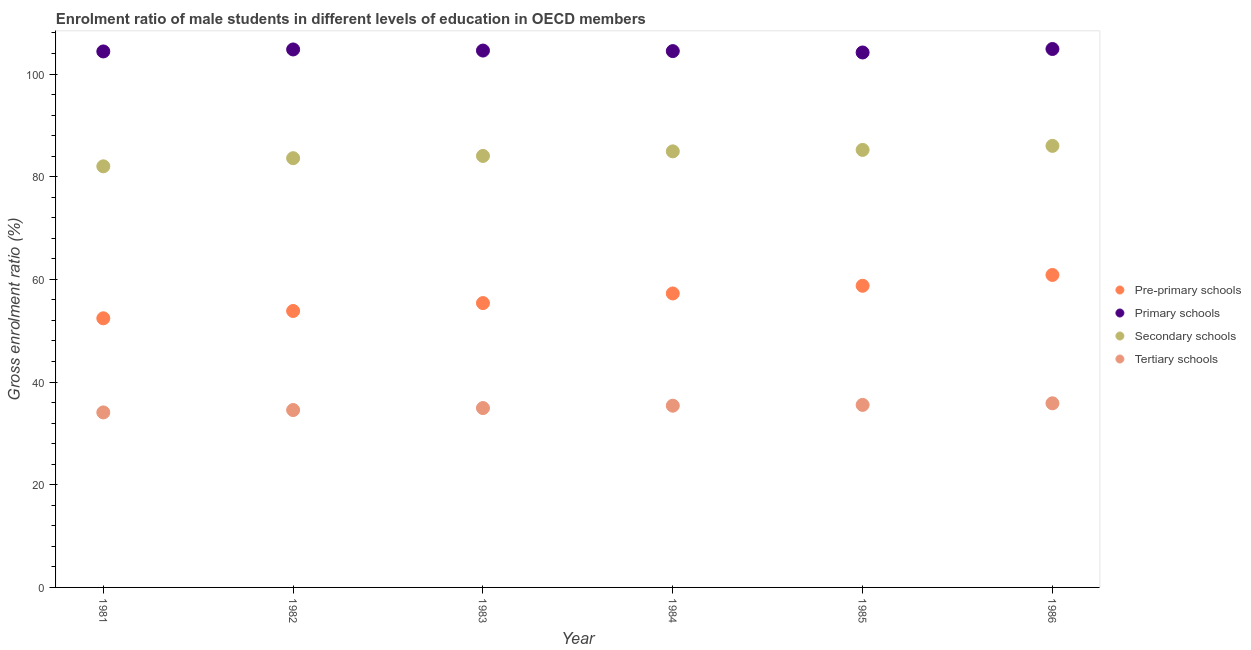How many different coloured dotlines are there?
Give a very brief answer. 4. What is the gross enrolment ratio(female) in primary schools in 1986?
Give a very brief answer. 104.87. Across all years, what is the maximum gross enrolment ratio(female) in primary schools?
Keep it short and to the point. 104.87. Across all years, what is the minimum gross enrolment ratio(female) in pre-primary schools?
Give a very brief answer. 52.42. What is the total gross enrolment ratio(female) in primary schools in the graph?
Give a very brief answer. 627.28. What is the difference between the gross enrolment ratio(female) in secondary schools in 1982 and that in 1986?
Provide a succinct answer. -2.4. What is the difference between the gross enrolment ratio(female) in pre-primary schools in 1985 and the gross enrolment ratio(female) in secondary schools in 1981?
Offer a very short reply. -23.27. What is the average gross enrolment ratio(female) in secondary schools per year?
Keep it short and to the point. 84.3. In the year 1981, what is the difference between the gross enrolment ratio(female) in primary schools and gross enrolment ratio(female) in tertiary schools?
Offer a very short reply. 70.31. What is the ratio of the gross enrolment ratio(female) in pre-primary schools in 1981 to that in 1983?
Provide a succinct answer. 0.95. Is the difference between the gross enrolment ratio(female) in pre-primary schools in 1982 and 1985 greater than the difference between the gross enrolment ratio(female) in primary schools in 1982 and 1985?
Offer a terse response. No. What is the difference between the highest and the second highest gross enrolment ratio(female) in primary schools?
Ensure brevity in your answer.  0.09. What is the difference between the highest and the lowest gross enrolment ratio(female) in secondary schools?
Your answer should be compact. 3.98. How many years are there in the graph?
Your answer should be compact. 6. Are the values on the major ticks of Y-axis written in scientific E-notation?
Your response must be concise. No. Where does the legend appear in the graph?
Your answer should be compact. Center right. How are the legend labels stacked?
Give a very brief answer. Vertical. What is the title of the graph?
Your answer should be compact. Enrolment ratio of male students in different levels of education in OECD members. What is the label or title of the Y-axis?
Offer a very short reply. Gross enrolment ratio (%). What is the Gross enrolment ratio (%) in Pre-primary schools in 1981?
Ensure brevity in your answer.  52.42. What is the Gross enrolment ratio (%) of Primary schools in 1981?
Ensure brevity in your answer.  104.4. What is the Gross enrolment ratio (%) in Secondary schools in 1981?
Keep it short and to the point. 82.02. What is the Gross enrolment ratio (%) in Tertiary schools in 1981?
Provide a succinct answer. 34.09. What is the Gross enrolment ratio (%) in Pre-primary schools in 1982?
Make the answer very short. 53.84. What is the Gross enrolment ratio (%) of Primary schools in 1982?
Provide a succinct answer. 104.78. What is the Gross enrolment ratio (%) of Secondary schools in 1982?
Your answer should be compact. 83.6. What is the Gross enrolment ratio (%) of Tertiary schools in 1982?
Make the answer very short. 34.55. What is the Gross enrolment ratio (%) in Pre-primary schools in 1983?
Offer a terse response. 55.38. What is the Gross enrolment ratio (%) in Primary schools in 1983?
Make the answer very short. 104.57. What is the Gross enrolment ratio (%) of Secondary schools in 1983?
Make the answer very short. 84.05. What is the Gross enrolment ratio (%) of Tertiary schools in 1983?
Make the answer very short. 34.94. What is the Gross enrolment ratio (%) in Pre-primary schools in 1984?
Your response must be concise. 57.26. What is the Gross enrolment ratio (%) of Primary schools in 1984?
Provide a short and direct response. 104.46. What is the Gross enrolment ratio (%) in Secondary schools in 1984?
Provide a succinct answer. 84.93. What is the Gross enrolment ratio (%) in Tertiary schools in 1984?
Offer a terse response. 35.4. What is the Gross enrolment ratio (%) of Pre-primary schools in 1985?
Your answer should be very brief. 58.76. What is the Gross enrolment ratio (%) of Primary schools in 1985?
Keep it short and to the point. 104.19. What is the Gross enrolment ratio (%) of Secondary schools in 1985?
Offer a very short reply. 85.22. What is the Gross enrolment ratio (%) of Tertiary schools in 1985?
Offer a very short reply. 35.55. What is the Gross enrolment ratio (%) of Pre-primary schools in 1986?
Keep it short and to the point. 60.86. What is the Gross enrolment ratio (%) in Primary schools in 1986?
Provide a short and direct response. 104.87. What is the Gross enrolment ratio (%) of Secondary schools in 1986?
Keep it short and to the point. 86. What is the Gross enrolment ratio (%) of Tertiary schools in 1986?
Keep it short and to the point. 35.86. Across all years, what is the maximum Gross enrolment ratio (%) in Pre-primary schools?
Provide a short and direct response. 60.86. Across all years, what is the maximum Gross enrolment ratio (%) in Primary schools?
Ensure brevity in your answer.  104.87. Across all years, what is the maximum Gross enrolment ratio (%) in Secondary schools?
Ensure brevity in your answer.  86. Across all years, what is the maximum Gross enrolment ratio (%) of Tertiary schools?
Keep it short and to the point. 35.86. Across all years, what is the minimum Gross enrolment ratio (%) of Pre-primary schools?
Your answer should be very brief. 52.42. Across all years, what is the minimum Gross enrolment ratio (%) in Primary schools?
Your response must be concise. 104.19. Across all years, what is the minimum Gross enrolment ratio (%) in Secondary schools?
Your answer should be very brief. 82.02. Across all years, what is the minimum Gross enrolment ratio (%) of Tertiary schools?
Make the answer very short. 34.09. What is the total Gross enrolment ratio (%) of Pre-primary schools in the graph?
Your answer should be compact. 338.52. What is the total Gross enrolment ratio (%) in Primary schools in the graph?
Give a very brief answer. 627.28. What is the total Gross enrolment ratio (%) of Secondary schools in the graph?
Your answer should be very brief. 505.83. What is the total Gross enrolment ratio (%) in Tertiary schools in the graph?
Your answer should be very brief. 210.39. What is the difference between the Gross enrolment ratio (%) in Pre-primary schools in 1981 and that in 1982?
Your response must be concise. -1.42. What is the difference between the Gross enrolment ratio (%) of Primary schools in 1981 and that in 1982?
Offer a terse response. -0.39. What is the difference between the Gross enrolment ratio (%) of Secondary schools in 1981 and that in 1982?
Your answer should be compact. -1.58. What is the difference between the Gross enrolment ratio (%) of Tertiary schools in 1981 and that in 1982?
Your answer should be compact. -0.46. What is the difference between the Gross enrolment ratio (%) in Pre-primary schools in 1981 and that in 1983?
Provide a short and direct response. -2.96. What is the difference between the Gross enrolment ratio (%) of Primary schools in 1981 and that in 1983?
Offer a very short reply. -0.17. What is the difference between the Gross enrolment ratio (%) in Secondary schools in 1981 and that in 1983?
Keep it short and to the point. -2.02. What is the difference between the Gross enrolment ratio (%) in Tertiary schools in 1981 and that in 1983?
Keep it short and to the point. -0.85. What is the difference between the Gross enrolment ratio (%) in Pre-primary schools in 1981 and that in 1984?
Offer a terse response. -4.84. What is the difference between the Gross enrolment ratio (%) in Primary schools in 1981 and that in 1984?
Offer a terse response. -0.07. What is the difference between the Gross enrolment ratio (%) in Secondary schools in 1981 and that in 1984?
Ensure brevity in your answer.  -2.91. What is the difference between the Gross enrolment ratio (%) in Tertiary schools in 1981 and that in 1984?
Your response must be concise. -1.31. What is the difference between the Gross enrolment ratio (%) in Pre-primary schools in 1981 and that in 1985?
Offer a terse response. -6.34. What is the difference between the Gross enrolment ratio (%) of Primary schools in 1981 and that in 1985?
Offer a very short reply. 0.2. What is the difference between the Gross enrolment ratio (%) of Secondary schools in 1981 and that in 1985?
Offer a terse response. -3.2. What is the difference between the Gross enrolment ratio (%) of Tertiary schools in 1981 and that in 1985?
Your response must be concise. -1.46. What is the difference between the Gross enrolment ratio (%) of Pre-primary schools in 1981 and that in 1986?
Provide a short and direct response. -8.44. What is the difference between the Gross enrolment ratio (%) of Primary schools in 1981 and that in 1986?
Keep it short and to the point. -0.48. What is the difference between the Gross enrolment ratio (%) of Secondary schools in 1981 and that in 1986?
Offer a terse response. -3.98. What is the difference between the Gross enrolment ratio (%) of Tertiary schools in 1981 and that in 1986?
Offer a very short reply. -1.78. What is the difference between the Gross enrolment ratio (%) of Pre-primary schools in 1982 and that in 1983?
Provide a succinct answer. -1.54. What is the difference between the Gross enrolment ratio (%) in Primary schools in 1982 and that in 1983?
Provide a succinct answer. 0.21. What is the difference between the Gross enrolment ratio (%) of Secondary schools in 1982 and that in 1983?
Offer a terse response. -0.44. What is the difference between the Gross enrolment ratio (%) of Tertiary schools in 1982 and that in 1983?
Offer a terse response. -0.39. What is the difference between the Gross enrolment ratio (%) of Pre-primary schools in 1982 and that in 1984?
Make the answer very short. -3.42. What is the difference between the Gross enrolment ratio (%) in Primary schools in 1982 and that in 1984?
Ensure brevity in your answer.  0.32. What is the difference between the Gross enrolment ratio (%) in Secondary schools in 1982 and that in 1984?
Make the answer very short. -1.33. What is the difference between the Gross enrolment ratio (%) in Tertiary schools in 1982 and that in 1984?
Give a very brief answer. -0.85. What is the difference between the Gross enrolment ratio (%) in Pre-primary schools in 1982 and that in 1985?
Ensure brevity in your answer.  -4.91. What is the difference between the Gross enrolment ratio (%) in Primary schools in 1982 and that in 1985?
Your answer should be very brief. 0.59. What is the difference between the Gross enrolment ratio (%) in Secondary schools in 1982 and that in 1985?
Your answer should be very brief. -1.62. What is the difference between the Gross enrolment ratio (%) in Tertiary schools in 1982 and that in 1985?
Keep it short and to the point. -1. What is the difference between the Gross enrolment ratio (%) in Pre-primary schools in 1982 and that in 1986?
Offer a terse response. -7.02. What is the difference between the Gross enrolment ratio (%) in Primary schools in 1982 and that in 1986?
Offer a very short reply. -0.09. What is the difference between the Gross enrolment ratio (%) in Secondary schools in 1982 and that in 1986?
Your response must be concise. -2.4. What is the difference between the Gross enrolment ratio (%) in Tertiary schools in 1982 and that in 1986?
Provide a succinct answer. -1.31. What is the difference between the Gross enrolment ratio (%) in Pre-primary schools in 1983 and that in 1984?
Provide a succinct answer. -1.88. What is the difference between the Gross enrolment ratio (%) of Primary schools in 1983 and that in 1984?
Your answer should be compact. 0.1. What is the difference between the Gross enrolment ratio (%) in Secondary schools in 1983 and that in 1984?
Give a very brief answer. -0.89. What is the difference between the Gross enrolment ratio (%) of Tertiary schools in 1983 and that in 1984?
Provide a succinct answer. -0.46. What is the difference between the Gross enrolment ratio (%) in Pre-primary schools in 1983 and that in 1985?
Your answer should be very brief. -3.37. What is the difference between the Gross enrolment ratio (%) of Primary schools in 1983 and that in 1985?
Make the answer very short. 0.38. What is the difference between the Gross enrolment ratio (%) in Secondary schools in 1983 and that in 1985?
Your response must be concise. -1.17. What is the difference between the Gross enrolment ratio (%) of Tertiary schools in 1983 and that in 1985?
Keep it short and to the point. -0.62. What is the difference between the Gross enrolment ratio (%) of Pre-primary schools in 1983 and that in 1986?
Make the answer very short. -5.48. What is the difference between the Gross enrolment ratio (%) of Primary schools in 1983 and that in 1986?
Provide a short and direct response. -0.3. What is the difference between the Gross enrolment ratio (%) of Secondary schools in 1983 and that in 1986?
Provide a succinct answer. -1.96. What is the difference between the Gross enrolment ratio (%) in Tertiary schools in 1983 and that in 1986?
Give a very brief answer. -0.93. What is the difference between the Gross enrolment ratio (%) of Pre-primary schools in 1984 and that in 1985?
Make the answer very short. -1.5. What is the difference between the Gross enrolment ratio (%) of Primary schools in 1984 and that in 1985?
Keep it short and to the point. 0.27. What is the difference between the Gross enrolment ratio (%) in Secondary schools in 1984 and that in 1985?
Make the answer very short. -0.29. What is the difference between the Gross enrolment ratio (%) of Tertiary schools in 1984 and that in 1985?
Make the answer very short. -0.15. What is the difference between the Gross enrolment ratio (%) of Pre-primary schools in 1984 and that in 1986?
Provide a succinct answer. -3.6. What is the difference between the Gross enrolment ratio (%) of Primary schools in 1984 and that in 1986?
Keep it short and to the point. -0.41. What is the difference between the Gross enrolment ratio (%) of Secondary schools in 1984 and that in 1986?
Keep it short and to the point. -1.07. What is the difference between the Gross enrolment ratio (%) in Tertiary schools in 1984 and that in 1986?
Your response must be concise. -0.47. What is the difference between the Gross enrolment ratio (%) of Pre-primary schools in 1985 and that in 1986?
Your response must be concise. -2.1. What is the difference between the Gross enrolment ratio (%) in Primary schools in 1985 and that in 1986?
Your response must be concise. -0.68. What is the difference between the Gross enrolment ratio (%) in Secondary schools in 1985 and that in 1986?
Offer a terse response. -0.78. What is the difference between the Gross enrolment ratio (%) in Tertiary schools in 1985 and that in 1986?
Give a very brief answer. -0.31. What is the difference between the Gross enrolment ratio (%) of Pre-primary schools in 1981 and the Gross enrolment ratio (%) of Primary schools in 1982?
Your response must be concise. -52.36. What is the difference between the Gross enrolment ratio (%) of Pre-primary schools in 1981 and the Gross enrolment ratio (%) of Secondary schools in 1982?
Your answer should be compact. -31.19. What is the difference between the Gross enrolment ratio (%) in Pre-primary schools in 1981 and the Gross enrolment ratio (%) in Tertiary schools in 1982?
Make the answer very short. 17.87. What is the difference between the Gross enrolment ratio (%) in Primary schools in 1981 and the Gross enrolment ratio (%) in Secondary schools in 1982?
Make the answer very short. 20.79. What is the difference between the Gross enrolment ratio (%) in Primary schools in 1981 and the Gross enrolment ratio (%) in Tertiary schools in 1982?
Give a very brief answer. 69.85. What is the difference between the Gross enrolment ratio (%) of Secondary schools in 1981 and the Gross enrolment ratio (%) of Tertiary schools in 1982?
Make the answer very short. 47.47. What is the difference between the Gross enrolment ratio (%) in Pre-primary schools in 1981 and the Gross enrolment ratio (%) in Primary schools in 1983?
Keep it short and to the point. -52.15. What is the difference between the Gross enrolment ratio (%) in Pre-primary schools in 1981 and the Gross enrolment ratio (%) in Secondary schools in 1983?
Your response must be concise. -31.63. What is the difference between the Gross enrolment ratio (%) in Pre-primary schools in 1981 and the Gross enrolment ratio (%) in Tertiary schools in 1983?
Make the answer very short. 17.48. What is the difference between the Gross enrolment ratio (%) in Primary schools in 1981 and the Gross enrolment ratio (%) in Secondary schools in 1983?
Ensure brevity in your answer.  20.35. What is the difference between the Gross enrolment ratio (%) in Primary schools in 1981 and the Gross enrolment ratio (%) in Tertiary schools in 1983?
Provide a short and direct response. 69.46. What is the difference between the Gross enrolment ratio (%) of Secondary schools in 1981 and the Gross enrolment ratio (%) of Tertiary schools in 1983?
Provide a succinct answer. 47.09. What is the difference between the Gross enrolment ratio (%) in Pre-primary schools in 1981 and the Gross enrolment ratio (%) in Primary schools in 1984?
Offer a terse response. -52.05. What is the difference between the Gross enrolment ratio (%) in Pre-primary schools in 1981 and the Gross enrolment ratio (%) in Secondary schools in 1984?
Offer a very short reply. -32.51. What is the difference between the Gross enrolment ratio (%) in Pre-primary schools in 1981 and the Gross enrolment ratio (%) in Tertiary schools in 1984?
Your response must be concise. 17.02. What is the difference between the Gross enrolment ratio (%) of Primary schools in 1981 and the Gross enrolment ratio (%) of Secondary schools in 1984?
Ensure brevity in your answer.  19.46. What is the difference between the Gross enrolment ratio (%) in Primary schools in 1981 and the Gross enrolment ratio (%) in Tertiary schools in 1984?
Give a very brief answer. 69. What is the difference between the Gross enrolment ratio (%) of Secondary schools in 1981 and the Gross enrolment ratio (%) of Tertiary schools in 1984?
Ensure brevity in your answer.  46.62. What is the difference between the Gross enrolment ratio (%) of Pre-primary schools in 1981 and the Gross enrolment ratio (%) of Primary schools in 1985?
Offer a very short reply. -51.78. What is the difference between the Gross enrolment ratio (%) of Pre-primary schools in 1981 and the Gross enrolment ratio (%) of Secondary schools in 1985?
Your answer should be very brief. -32.8. What is the difference between the Gross enrolment ratio (%) of Pre-primary schools in 1981 and the Gross enrolment ratio (%) of Tertiary schools in 1985?
Make the answer very short. 16.87. What is the difference between the Gross enrolment ratio (%) of Primary schools in 1981 and the Gross enrolment ratio (%) of Secondary schools in 1985?
Offer a terse response. 19.18. What is the difference between the Gross enrolment ratio (%) in Primary schools in 1981 and the Gross enrolment ratio (%) in Tertiary schools in 1985?
Your answer should be compact. 68.84. What is the difference between the Gross enrolment ratio (%) in Secondary schools in 1981 and the Gross enrolment ratio (%) in Tertiary schools in 1985?
Your response must be concise. 46.47. What is the difference between the Gross enrolment ratio (%) in Pre-primary schools in 1981 and the Gross enrolment ratio (%) in Primary schools in 1986?
Give a very brief answer. -52.45. What is the difference between the Gross enrolment ratio (%) of Pre-primary schools in 1981 and the Gross enrolment ratio (%) of Secondary schools in 1986?
Offer a very short reply. -33.58. What is the difference between the Gross enrolment ratio (%) of Pre-primary schools in 1981 and the Gross enrolment ratio (%) of Tertiary schools in 1986?
Provide a succinct answer. 16.56. What is the difference between the Gross enrolment ratio (%) of Primary schools in 1981 and the Gross enrolment ratio (%) of Secondary schools in 1986?
Your response must be concise. 18.39. What is the difference between the Gross enrolment ratio (%) of Primary schools in 1981 and the Gross enrolment ratio (%) of Tertiary schools in 1986?
Your response must be concise. 68.53. What is the difference between the Gross enrolment ratio (%) in Secondary schools in 1981 and the Gross enrolment ratio (%) in Tertiary schools in 1986?
Your response must be concise. 46.16. What is the difference between the Gross enrolment ratio (%) in Pre-primary schools in 1982 and the Gross enrolment ratio (%) in Primary schools in 1983?
Offer a very short reply. -50.73. What is the difference between the Gross enrolment ratio (%) in Pre-primary schools in 1982 and the Gross enrolment ratio (%) in Secondary schools in 1983?
Your answer should be very brief. -30.2. What is the difference between the Gross enrolment ratio (%) of Pre-primary schools in 1982 and the Gross enrolment ratio (%) of Tertiary schools in 1983?
Ensure brevity in your answer.  18.91. What is the difference between the Gross enrolment ratio (%) of Primary schools in 1982 and the Gross enrolment ratio (%) of Secondary schools in 1983?
Ensure brevity in your answer.  20.74. What is the difference between the Gross enrolment ratio (%) of Primary schools in 1982 and the Gross enrolment ratio (%) of Tertiary schools in 1983?
Give a very brief answer. 69.85. What is the difference between the Gross enrolment ratio (%) in Secondary schools in 1982 and the Gross enrolment ratio (%) in Tertiary schools in 1983?
Your answer should be compact. 48.67. What is the difference between the Gross enrolment ratio (%) in Pre-primary schools in 1982 and the Gross enrolment ratio (%) in Primary schools in 1984?
Your response must be concise. -50.62. What is the difference between the Gross enrolment ratio (%) in Pre-primary schools in 1982 and the Gross enrolment ratio (%) in Secondary schools in 1984?
Keep it short and to the point. -31.09. What is the difference between the Gross enrolment ratio (%) of Pre-primary schools in 1982 and the Gross enrolment ratio (%) of Tertiary schools in 1984?
Provide a succinct answer. 18.45. What is the difference between the Gross enrolment ratio (%) of Primary schools in 1982 and the Gross enrolment ratio (%) of Secondary schools in 1984?
Your answer should be compact. 19.85. What is the difference between the Gross enrolment ratio (%) in Primary schools in 1982 and the Gross enrolment ratio (%) in Tertiary schools in 1984?
Offer a terse response. 69.39. What is the difference between the Gross enrolment ratio (%) of Secondary schools in 1982 and the Gross enrolment ratio (%) of Tertiary schools in 1984?
Your answer should be very brief. 48.21. What is the difference between the Gross enrolment ratio (%) in Pre-primary schools in 1982 and the Gross enrolment ratio (%) in Primary schools in 1985?
Ensure brevity in your answer.  -50.35. What is the difference between the Gross enrolment ratio (%) in Pre-primary schools in 1982 and the Gross enrolment ratio (%) in Secondary schools in 1985?
Offer a very short reply. -31.38. What is the difference between the Gross enrolment ratio (%) in Pre-primary schools in 1982 and the Gross enrolment ratio (%) in Tertiary schools in 1985?
Keep it short and to the point. 18.29. What is the difference between the Gross enrolment ratio (%) of Primary schools in 1982 and the Gross enrolment ratio (%) of Secondary schools in 1985?
Your answer should be compact. 19.56. What is the difference between the Gross enrolment ratio (%) of Primary schools in 1982 and the Gross enrolment ratio (%) of Tertiary schools in 1985?
Offer a very short reply. 69.23. What is the difference between the Gross enrolment ratio (%) in Secondary schools in 1982 and the Gross enrolment ratio (%) in Tertiary schools in 1985?
Provide a succinct answer. 48.05. What is the difference between the Gross enrolment ratio (%) of Pre-primary schools in 1982 and the Gross enrolment ratio (%) of Primary schools in 1986?
Make the answer very short. -51.03. What is the difference between the Gross enrolment ratio (%) in Pre-primary schools in 1982 and the Gross enrolment ratio (%) in Secondary schools in 1986?
Your answer should be compact. -32.16. What is the difference between the Gross enrolment ratio (%) in Pre-primary schools in 1982 and the Gross enrolment ratio (%) in Tertiary schools in 1986?
Give a very brief answer. 17.98. What is the difference between the Gross enrolment ratio (%) in Primary schools in 1982 and the Gross enrolment ratio (%) in Secondary schools in 1986?
Your response must be concise. 18.78. What is the difference between the Gross enrolment ratio (%) of Primary schools in 1982 and the Gross enrolment ratio (%) of Tertiary schools in 1986?
Your response must be concise. 68.92. What is the difference between the Gross enrolment ratio (%) of Secondary schools in 1982 and the Gross enrolment ratio (%) of Tertiary schools in 1986?
Your response must be concise. 47.74. What is the difference between the Gross enrolment ratio (%) in Pre-primary schools in 1983 and the Gross enrolment ratio (%) in Primary schools in 1984?
Keep it short and to the point. -49.08. What is the difference between the Gross enrolment ratio (%) in Pre-primary schools in 1983 and the Gross enrolment ratio (%) in Secondary schools in 1984?
Keep it short and to the point. -29.55. What is the difference between the Gross enrolment ratio (%) in Pre-primary schools in 1983 and the Gross enrolment ratio (%) in Tertiary schools in 1984?
Offer a terse response. 19.98. What is the difference between the Gross enrolment ratio (%) in Primary schools in 1983 and the Gross enrolment ratio (%) in Secondary schools in 1984?
Give a very brief answer. 19.64. What is the difference between the Gross enrolment ratio (%) in Primary schools in 1983 and the Gross enrolment ratio (%) in Tertiary schools in 1984?
Your response must be concise. 69.17. What is the difference between the Gross enrolment ratio (%) in Secondary schools in 1983 and the Gross enrolment ratio (%) in Tertiary schools in 1984?
Keep it short and to the point. 48.65. What is the difference between the Gross enrolment ratio (%) of Pre-primary schools in 1983 and the Gross enrolment ratio (%) of Primary schools in 1985?
Your answer should be very brief. -48.81. What is the difference between the Gross enrolment ratio (%) of Pre-primary schools in 1983 and the Gross enrolment ratio (%) of Secondary schools in 1985?
Ensure brevity in your answer.  -29.84. What is the difference between the Gross enrolment ratio (%) in Pre-primary schools in 1983 and the Gross enrolment ratio (%) in Tertiary schools in 1985?
Provide a succinct answer. 19.83. What is the difference between the Gross enrolment ratio (%) of Primary schools in 1983 and the Gross enrolment ratio (%) of Secondary schools in 1985?
Make the answer very short. 19.35. What is the difference between the Gross enrolment ratio (%) in Primary schools in 1983 and the Gross enrolment ratio (%) in Tertiary schools in 1985?
Keep it short and to the point. 69.02. What is the difference between the Gross enrolment ratio (%) of Secondary schools in 1983 and the Gross enrolment ratio (%) of Tertiary schools in 1985?
Keep it short and to the point. 48.49. What is the difference between the Gross enrolment ratio (%) in Pre-primary schools in 1983 and the Gross enrolment ratio (%) in Primary schools in 1986?
Ensure brevity in your answer.  -49.49. What is the difference between the Gross enrolment ratio (%) of Pre-primary schools in 1983 and the Gross enrolment ratio (%) of Secondary schools in 1986?
Ensure brevity in your answer.  -30.62. What is the difference between the Gross enrolment ratio (%) of Pre-primary schools in 1983 and the Gross enrolment ratio (%) of Tertiary schools in 1986?
Offer a very short reply. 19.52. What is the difference between the Gross enrolment ratio (%) in Primary schools in 1983 and the Gross enrolment ratio (%) in Secondary schools in 1986?
Keep it short and to the point. 18.57. What is the difference between the Gross enrolment ratio (%) in Primary schools in 1983 and the Gross enrolment ratio (%) in Tertiary schools in 1986?
Offer a very short reply. 68.71. What is the difference between the Gross enrolment ratio (%) in Secondary schools in 1983 and the Gross enrolment ratio (%) in Tertiary schools in 1986?
Your answer should be compact. 48.18. What is the difference between the Gross enrolment ratio (%) in Pre-primary schools in 1984 and the Gross enrolment ratio (%) in Primary schools in 1985?
Your answer should be compact. -46.94. What is the difference between the Gross enrolment ratio (%) in Pre-primary schools in 1984 and the Gross enrolment ratio (%) in Secondary schools in 1985?
Provide a succinct answer. -27.96. What is the difference between the Gross enrolment ratio (%) in Pre-primary schools in 1984 and the Gross enrolment ratio (%) in Tertiary schools in 1985?
Make the answer very short. 21.71. What is the difference between the Gross enrolment ratio (%) of Primary schools in 1984 and the Gross enrolment ratio (%) of Secondary schools in 1985?
Provide a succinct answer. 19.24. What is the difference between the Gross enrolment ratio (%) in Primary schools in 1984 and the Gross enrolment ratio (%) in Tertiary schools in 1985?
Provide a succinct answer. 68.91. What is the difference between the Gross enrolment ratio (%) in Secondary schools in 1984 and the Gross enrolment ratio (%) in Tertiary schools in 1985?
Your answer should be compact. 49.38. What is the difference between the Gross enrolment ratio (%) of Pre-primary schools in 1984 and the Gross enrolment ratio (%) of Primary schools in 1986?
Your answer should be compact. -47.62. What is the difference between the Gross enrolment ratio (%) in Pre-primary schools in 1984 and the Gross enrolment ratio (%) in Secondary schools in 1986?
Provide a succinct answer. -28.74. What is the difference between the Gross enrolment ratio (%) of Pre-primary schools in 1984 and the Gross enrolment ratio (%) of Tertiary schools in 1986?
Provide a succinct answer. 21.39. What is the difference between the Gross enrolment ratio (%) of Primary schools in 1984 and the Gross enrolment ratio (%) of Secondary schools in 1986?
Make the answer very short. 18.46. What is the difference between the Gross enrolment ratio (%) of Primary schools in 1984 and the Gross enrolment ratio (%) of Tertiary schools in 1986?
Keep it short and to the point. 68.6. What is the difference between the Gross enrolment ratio (%) in Secondary schools in 1984 and the Gross enrolment ratio (%) in Tertiary schools in 1986?
Your answer should be very brief. 49.07. What is the difference between the Gross enrolment ratio (%) of Pre-primary schools in 1985 and the Gross enrolment ratio (%) of Primary schools in 1986?
Your response must be concise. -46.12. What is the difference between the Gross enrolment ratio (%) in Pre-primary schools in 1985 and the Gross enrolment ratio (%) in Secondary schools in 1986?
Ensure brevity in your answer.  -27.25. What is the difference between the Gross enrolment ratio (%) in Pre-primary schools in 1985 and the Gross enrolment ratio (%) in Tertiary schools in 1986?
Provide a short and direct response. 22.89. What is the difference between the Gross enrolment ratio (%) in Primary schools in 1985 and the Gross enrolment ratio (%) in Secondary schools in 1986?
Provide a succinct answer. 18.19. What is the difference between the Gross enrolment ratio (%) of Primary schools in 1985 and the Gross enrolment ratio (%) of Tertiary schools in 1986?
Give a very brief answer. 68.33. What is the difference between the Gross enrolment ratio (%) in Secondary schools in 1985 and the Gross enrolment ratio (%) in Tertiary schools in 1986?
Provide a short and direct response. 49.36. What is the average Gross enrolment ratio (%) of Pre-primary schools per year?
Ensure brevity in your answer.  56.42. What is the average Gross enrolment ratio (%) of Primary schools per year?
Provide a succinct answer. 104.55. What is the average Gross enrolment ratio (%) in Secondary schools per year?
Your answer should be compact. 84.3. What is the average Gross enrolment ratio (%) of Tertiary schools per year?
Your response must be concise. 35.06. In the year 1981, what is the difference between the Gross enrolment ratio (%) of Pre-primary schools and Gross enrolment ratio (%) of Primary schools?
Give a very brief answer. -51.98. In the year 1981, what is the difference between the Gross enrolment ratio (%) in Pre-primary schools and Gross enrolment ratio (%) in Secondary schools?
Offer a terse response. -29.6. In the year 1981, what is the difference between the Gross enrolment ratio (%) in Pre-primary schools and Gross enrolment ratio (%) in Tertiary schools?
Your response must be concise. 18.33. In the year 1981, what is the difference between the Gross enrolment ratio (%) in Primary schools and Gross enrolment ratio (%) in Secondary schools?
Your response must be concise. 22.37. In the year 1981, what is the difference between the Gross enrolment ratio (%) in Primary schools and Gross enrolment ratio (%) in Tertiary schools?
Offer a very short reply. 70.31. In the year 1981, what is the difference between the Gross enrolment ratio (%) of Secondary schools and Gross enrolment ratio (%) of Tertiary schools?
Ensure brevity in your answer.  47.94. In the year 1982, what is the difference between the Gross enrolment ratio (%) in Pre-primary schools and Gross enrolment ratio (%) in Primary schools?
Offer a very short reply. -50.94. In the year 1982, what is the difference between the Gross enrolment ratio (%) in Pre-primary schools and Gross enrolment ratio (%) in Secondary schools?
Your answer should be compact. -29.76. In the year 1982, what is the difference between the Gross enrolment ratio (%) in Pre-primary schools and Gross enrolment ratio (%) in Tertiary schools?
Make the answer very short. 19.29. In the year 1982, what is the difference between the Gross enrolment ratio (%) of Primary schools and Gross enrolment ratio (%) of Secondary schools?
Offer a terse response. 21.18. In the year 1982, what is the difference between the Gross enrolment ratio (%) in Primary schools and Gross enrolment ratio (%) in Tertiary schools?
Make the answer very short. 70.23. In the year 1982, what is the difference between the Gross enrolment ratio (%) of Secondary schools and Gross enrolment ratio (%) of Tertiary schools?
Provide a succinct answer. 49.05. In the year 1983, what is the difference between the Gross enrolment ratio (%) of Pre-primary schools and Gross enrolment ratio (%) of Primary schools?
Give a very brief answer. -49.19. In the year 1983, what is the difference between the Gross enrolment ratio (%) of Pre-primary schools and Gross enrolment ratio (%) of Secondary schools?
Keep it short and to the point. -28.66. In the year 1983, what is the difference between the Gross enrolment ratio (%) of Pre-primary schools and Gross enrolment ratio (%) of Tertiary schools?
Give a very brief answer. 20.45. In the year 1983, what is the difference between the Gross enrolment ratio (%) of Primary schools and Gross enrolment ratio (%) of Secondary schools?
Give a very brief answer. 20.52. In the year 1983, what is the difference between the Gross enrolment ratio (%) of Primary schools and Gross enrolment ratio (%) of Tertiary schools?
Give a very brief answer. 69.63. In the year 1983, what is the difference between the Gross enrolment ratio (%) of Secondary schools and Gross enrolment ratio (%) of Tertiary schools?
Give a very brief answer. 49.11. In the year 1984, what is the difference between the Gross enrolment ratio (%) in Pre-primary schools and Gross enrolment ratio (%) in Primary schools?
Provide a succinct answer. -47.21. In the year 1984, what is the difference between the Gross enrolment ratio (%) of Pre-primary schools and Gross enrolment ratio (%) of Secondary schools?
Provide a succinct answer. -27.67. In the year 1984, what is the difference between the Gross enrolment ratio (%) in Pre-primary schools and Gross enrolment ratio (%) in Tertiary schools?
Offer a terse response. 21.86. In the year 1984, what is the difference between the Gross enrolment ratio (%) in Primary schools and Gross enrolment ratio (%) in Secondary schools?
Make the answer very short. 19.53. In the year 1984, what is the difference between the Gross enrolment ratio (%) in Primary schools and Gross enrolment ratio (%) in Tertiary schools?
Offer a terse response. 69.07. In the year 1984, what is the difference between the Gross enrolment ratio (%) in Secondary schools and Gross enrolment ratio (%) in Tertiary schools?
Ensure brevity in your answer.  49.53. In the year 1985, what is the difference between the Gross enrolment ratio (%) of Pre-primary schools and Gross enrolment ratio (%) of Primary schools?
Give a very brief answer. -45.44. In the year 1985, what is the difference between the Gross enrolment ratio (%) of Pre-primary schools and Gross enrolment ratio (%) of Secondary schools?
Keep it short and to the point. -26.46. In the year 1985, what is the difference between the Gross enrolment ratio (%) of Pre-primary schools and Gross enrolment ratio (%) of Tertiary schools?
Keep it short and to the point. 23.2. In the year 1985, what is the difference between the Gross enrolment ratio (%) in Primary schools and Gross enrolment ratio (%) in Secondary schools?
Keep it short and to the point. 18.97. In the year 1985, what is the difference between the Gross enrolment ratio (%) of Primary schools and Gross enrolment ratio (%) of Tertiary schools?
Provide a short and direct response. 68.64. In the year 1985, what is the difference between the Gross enrolment ratio (%) of Secondary schools and Gross enrolment ratio (%) of Tertiary schools?
Provide a succinct answer. 49.67. In the year 1986, what is the difference between the Gross enrolment ratio (%) in Pre-primary schools and Gross enrolment ratio (%) in Primary schools?
Ensure brevity in your answer.  -44.01. In the year 1986, what is the difference between the Gross enrolment ratio (%) of Pre-primary schools and Gross enrolment ratio (%) of Secondary schools?
Ensure brevity in your answer.  -25.14. In the year 1986, what is the difference between the Gross enrolment ratio (%) of Pre-primary schools and Gross enrolment ratio (%) of Tertiary schools?
Your answer should be compact. 25. In the year 1986, what is the difference between the Gross enrolment ratio (%) of Primary schools and Gross enrolment ratio (%) of Secondary schools?
Offer a terse response. 18.87. In the year 1986, what is the difference between the Gross enrolment ratio (%) of Primary schools and Gross enrolment ratio (%) of Tertiary schools?
Provide a succinct answer. 69.01. In the year 1986, what is the difference between the Gross enrolment ratio (%) of Secondary schools and Gross enrolment ratio (%) of Tertiary schools?
Offer a terse response. 50.14. What is the ratio of the Gross enrolment ratio (%) of Pre-primary schools in 1981 to that in 1982?
Offer a terse response. 0.97. What is the ratio of the Gross enrolment ratio (%) of Secondary schools in 1981 to that in 1982?
Provide a short and direct response. 0.98. What is the ratio of the Gross enrolment ratio (%) of Tertiary schools in 1981 to that in 1982?
Your answer should be compact. 0.99. What is the ratio of the Gross enrolment ratio (%) in Pre-primary schools in 1981 to that in 1983?
Your answer should be compact. 0.95. What is the ratio of the Gross enrolment ratio (%) of Secondary schools in 1981 to that in 1983?
Offer a very short reply. 0.98. What is the ratio of the Gross enrolment ratio (%) of Tertiary schools in 1981 to that in 1983?
Your answer should be compact. 0.98. What is the ratio of the Gross enrolment ratio (%) of Pre-primary schools in 1981 to that in 1984?
Offer a terse response. 0.92. What is the ratio of the Gross enrolment ratio (%) in Primary schools in 1981 to that in 1984?
Ensure brevity in your answer.  1. What is the ratio of the Gross enrolment ratio (%) in Secondary schools in 1981 to that in 1984?
Provide a short and direct response. 0.97. What is the ratio of the Gross enrolment ratio (%) in Tertiary schools in 1981 to that in 1984?
Your answer should be very brief. 0.96. What is the ratio of the Gross enrolment ratio (%) in Pre-primary schools in 1981 to that in 1985?
Give a very brief answer. 0.89. What is the ratio of the Gross enrolment ratio (%) in Primary schools in 1981 to that in 1985?
Offer a terse response. 1. What is the ratio of the Gross enrolment ratio (%) in Secondary schools in 1981 to that in 1985?
Make the answer very short. 0.96. What is the ratio of the Gross enrolment ratio (%) of Tertiary schools in 1981 to that in 1985?
Provide a succinct answer. 0.96. What is the ratio of the Gross enrolment ratio (%) of Pre-primary schools in 1981 to that in 1986?
Provide a succinct answer. 0.86. What is the ratio of the Gross enrolment ratio (%) of Secondary schools in 1981 to that in 1986?
Provide a short and direct response. 0.95. What is the ratio of the Gross enrolment ratio (%) in Tertiary schools in 1981 to that in 1986?
Provide a short and direct response. 0.95. What is the ratio of the Gross enrolment ratio (%) of Pre-primary schools in 1982 to that in 1983?
Offer a terse response. 0.97. What is the ratio of the Gross enrolment ratio (%) in Pre-primary schools in 1982 to that in 1984?
Provide a succinct answer. 0.94. What is the ratio of the Gross enrolment ratio (%) in Secondary schools in 1982 to that in 1984?
Your response must be concise. 0.98. What is the ratio of the Gross enrolment ratio (%) of Tertiary schools in 1982 to that in 1984?
Provide a succinct answer. 0.98. What is the ratio of the Gross enrolment ratio (%) of Pre-primary schools in 1982 to that in 1985?
Your answer should be compact. 0.92. What is the ratio of the Gross enrolment ratio (%) in Primary schools in 1982 to that in 1985?
Provide a short and direct response. 1.01. What is the ratio of the Gross enrolment ratio (%) in Secondary schools in 1982 to that in 1985?
Offer a very short reply. 0.98. What is the ratio of the Gross enrolment ratio (%) in Tertiary schools in 1982 to that in 1985?
Keep it short and to the point. 0.97. What is the ratio of the Gross enrolment ratio (%) of Pre-primary schools in 1982 to that in 1986?
Your answer should be compact. 0.88. What is the ratio of the Gross enrolment ratio (%) of Primary schools in 1982 to that in 1986?
Offer a very short reply. 1. What is the ratio of the Gross enrolment ratio (%) in Secondary schools in 1982 to that in 1986?
Keep it short and to the point. 0.97. What is the ratio of the Gross enrolment ratio (%) in Tertiary schools in 1982 to that in 1986?
Offer a very short reply. 0.96. What is the ratio of the Gross enrolment ratio (%) of Pre-primary schools in 1983 to that in 1984?
Give a very brief answer. 0.97. What is the ratio of the Gross enrolment ratio (%) of Secondary schools in 1983 to that in 1984?
Your answer should be compact. 0.99. What is the ratio of the Gross enrolment ratio (%) in Tertiary schools in 1983 to that in 1984?
Ensure brevity in your answer.  0.99. What is the ratio of the Gross enrolment ratio (%) in Pre-primary schools in 1983 to that in 1985?
Provide a short and direct response. 0.94. What is the ratio of the Gross enrolment ratio (%) of Secondary schools in 1983 to that in 1985?
Keep it short and to the point. 0.99. What is the ratio of the Gross enrolment ratio (%) of Tertiary schools in 1983 to that in 1985?
Make the answer very short. 0.98. What is the ratio of the Gross enrolment ratio (%) of Pre-primary schools in 1983 to that in 1986?
Keep it short and to the point. 0.91. What is the ratio of the Gross enrolment ratio (%) in Secondary schools in 1983 to that in 1986?
Your answer should be very brief. 0.98. What is the ratio of the Gross enrolment ratio (%) in Tertiary schools in 1983 to that in 1986?
Offer a terse response. 0.97. What is the ratio of the Gross enrolment ratio (%) of Pre-primary schools in 1984 to that in 1985?
Your response must be concise. 0.97. What is the ratio of the Gross enrolment ratio (%) of Tertiary schools in 1984 to that in 1985?
Your answer should be compact. 1. What is the ratio of the Gross enrolment ratio (%) of Pre-primary schools in 1984 to that in 1986?
Offer a very short reply. 0.94. What is the ratio of the Gross enrolment ratio (%) in Secondary schools in 1984 to that in 1986?
Ensure brevity in your answer.  0.99. What is the ratio of the Gross enrolment ratio (%) in Pre-primary schools in 1985 to that in 1986?
Provide a succinct answer. 0.97. What is the ratio of the Gross enrolment ratio (%) of Primary schools in 1985 to that in 1986?
Your answer should be very brief. 0.99. What is the ratio of the Gross enrolment ratio (%) of Secondary schools in 1985 to that in 1986?
Make the answer very short. 0.99. What is the ratio of the Gross enrolment ratio (%) in Tertiary schools in 1985 to that in 1986?
Your answer should be compact. 0.99. What is the difference between the highest and the second highest Gross enrolment ratio (%) in Pre-primary schools?
Offer a very short reply. 2.1. What is the difference between the highest and the second highest Gross enrolment ratio (%) of Primary schools?
Provide a succinct answer. 0.09. What is the difference between the highest and the second highest Gross enrolment ratio (%) in Secondary schools?
Your answer should be compact. 0.78. What is the difference between the highest and the second highest Gross enrolment ratio (%) in Tertiary schools?
Your answer should be very brief. 0.31. What is the difference between the highest and the lowest Gross enrolment ratio (%) of Pre-primary schools?
Offer a terse response. 8.44. What is the difference between the highest and the lowest Gross enrolment ratio (%) in Primary schools?
Keep it short and to the point. 0.68. What is the difference between the highest and the lowest Gross enrolment ratio (%) in Secondary schools?
Provide a short and direct response. 3.98. What is the difference between the highest and the lowest Gross enrolment ratio (%) of Tertiary schools?
Keep it short and to the point. 1.78. 